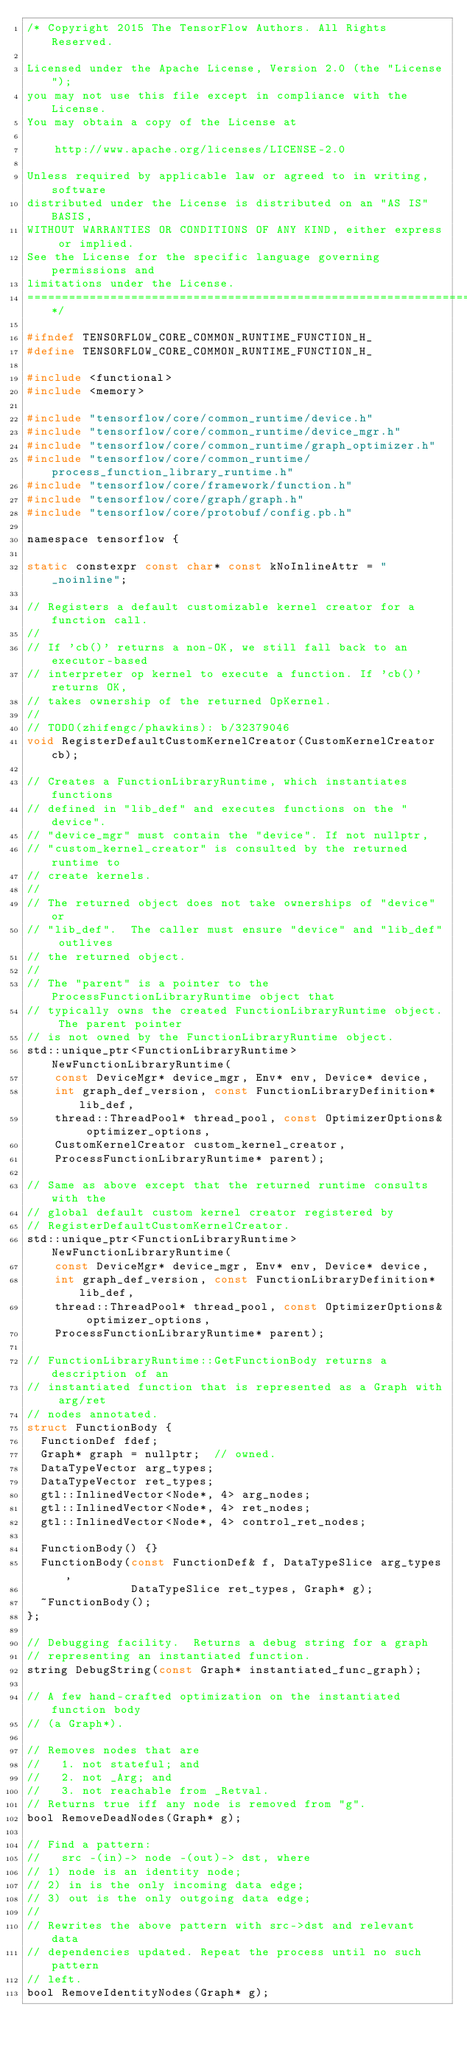Convert code to text. <code><loc_0><loc_0><loc_500><loc_500><_C_>/* Copyright 2015 The TensorFlow Authors. All Rights Reserved.

Licensed under the Apache License, Version 2.0 (the "License");
you may not use this file except in compliance with the License.
You may obtain a copy of the License at

    http://www.apache.org/licenses/LICENSE-2.0

Unless required by applicable law or agreed to in writing, software
distributed under the License is distributed on an "AS IS" BASIS,
WITHOUT WARRANTIES OR CONDITIONS OF ANY KIND, either express or implied.
See the License for the specific language governing permissions and
limitations under the License.
==============================================================================*/

#ifndef TENSORFLOW_CORE_COMMON_RUNTIME_FUNCTION_H_
#define TENSORFLOW_CORE_COMMON_RUNTIME_FUNCTION_H_

#include <functional>
#include <memory>

#include "tensorflow/core/common_runtime/device.h"
#include "tensorflow/core/common_runtime/device_mgr.h"
#include "tensorflow/core/common_runtime/graph_optimizer.h"
#include "tensorflow/core/common_runtime/process_function_library_runtime.h"
#include "tensorflow/core/framework/function.h"
#include "tensorflow/core/graph/graph.h"
#include "tensorflow/core/protobuf/config.pb.h"

namespace tensorflow {

static constexpr const char* const kNoInlineAttr = "_noinline";

// Registers a default customizable kernel creator for a function call.
//
// If 'cb()' returns a non-OK, we still fall back to an executor-based
// interpreter op kernel to execute a function. If 'cb()' returns OK,
// takes ownership of the returned OpKernel.
//
// TODO(zhifengc/phawkins): b/32379046
void RegisterDefaultCustomKernelCreator(CustomKernelCreator cb);

// Creates a FunctionLibraryRuntime, which instantiates functions
// defined in "lib_def" and executes functions on the "device".
// "device_mgr" must contain the "device". If not nullptr,
// "custom_kernel_creator" is consulted by the returned runtime to
// create kernels.
//
// The returned object does not take ownerships of "device" or
// "lib_def".  The caller must ensure "device" and "lib_def" outlives
// the returned object.
//
// The "parent" is a pointer to the ProcessFunctionLibraryRuntime object that
// typically owns the created FunctionLibraryRuntime object. The parent pointer
// is not owned by the FunctionLibraryRuntime object.
std::unique_ptr<FunctionLibraryRuntime> NewFunctionLibraryRuntime(
    const DeviceMgr* device_mgr, Env* env, Device* device,
    int graph_def_version, const FunctionLibraryDefinition* lib_def,
    thread::ThreadPool* thread_pool, const OptimizerOptions& optimizer_options,
    CustomKernelCreator custom_kernel_creator,
    ProcessFunctionLibraryRuntime* parent);

// Same as above except that the returned runtime consults with the
// global default custom kernel creator registered by
// RegisterDefaultCustomKernelCreator.
std::unique_ptr<FunctionLibraryRuntime> NewFunctionLibraryRuntime(
    const DeviceMgr* device_mgr, Env* env, Device* device,
    int graph_def_version, const FunctionLibraryDefinition* lib_def,
    thread::ThreadPool* thread_pool, const OptimizerOptions& optimizer_options,
    ProcessFunctionLibraryRuntime* parent);

// FunctionLibraryRuntime::GetFunctionBody returns a description of an
// instantiated function that is represented as a Graph with arg/ret
// nodes annotated.
struct FunctionBody {
  FunctionDef fdef;
  Graph* graph = nullptr;  // owned.
  DataTypeVector arg_types;
  DataTypeVector ret_types;
  gtl::InlinedVector<Node*, 4> arg_nodes;
  gtl::InlinedVector<Node*, 4> ret_nodes;
  gtl::InlinedVector<Node*, 4> control_ret_nodes;

  FunctionBody() {}
  FunctionBody(const FunctionDef& f, DataTypeSlice arg_types,
               DataTypeSlice ret_types, Graph* g);
  ~FunctionBody();
};

// Debugging facility.  Returns a debug string for a graph
// representing an instantiated function.
string DebugString(const Graph* instantiated_func_graph);

// A few hand-crafted optimization on the instantiated function body
// (a Graph*).

// Removes nodes that are
//   1. not stateful; and
//   2. not _Arg; and
//   3. not reachable from _Retval.
// Returns true iff any node is removed from "g".
bool RemoveDeadNodes(Graph* g);

// Find a pattern:
//   src -(in)-> node -(out)-> dst, where
// 1) node is an identity node;
// 2) in is the only incoming data edge;
// 3) out is the only outgoing data edge;
//
// Rewrites the above pattern with src->dst and relevant data
// dependencies updated. Repeat the process until no such pattern
// left.
bool RemoveIdentityNodes(Graph* g);
</code> 